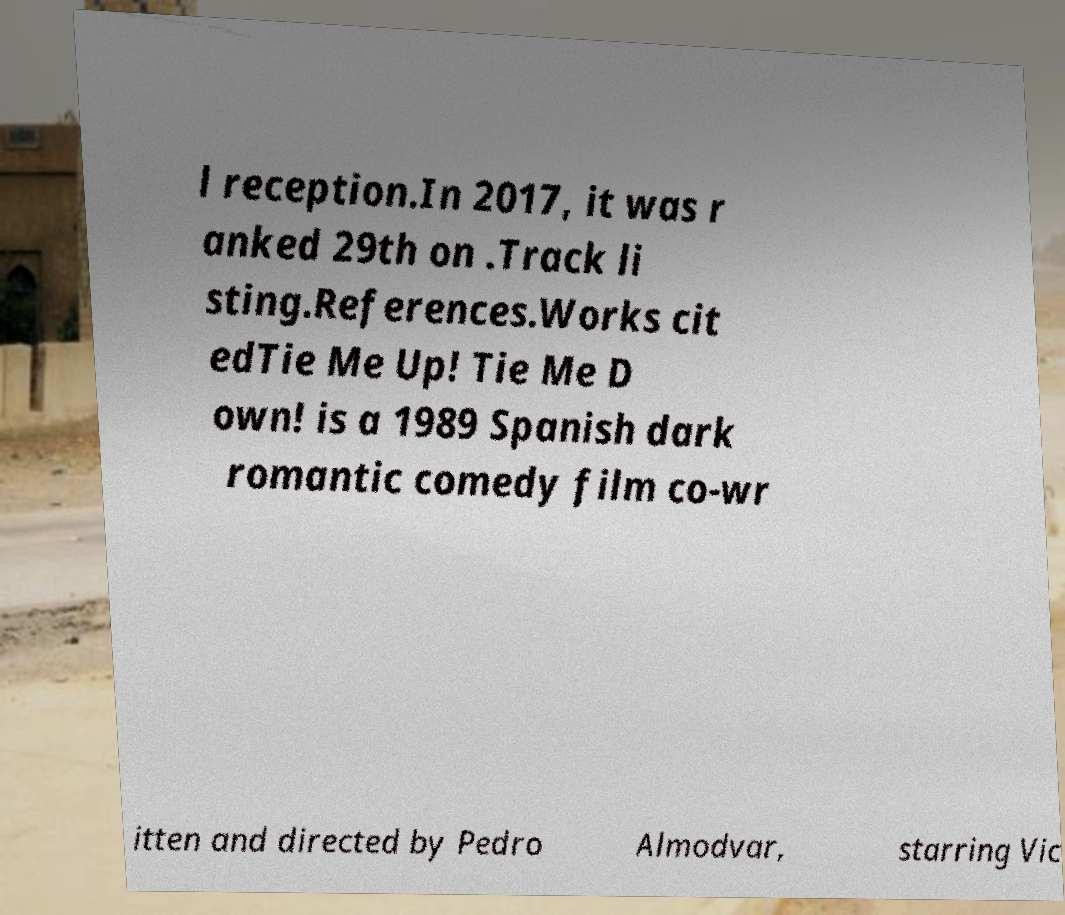Can you read and provide the text displayed in the image?This photo seems to have some interesting text. Can you extract and type it out for me? l reception.In 2017, it was r anked 29th on .Track li sting.References.Works cit edTie Me Up! Tie Me D own! is a 1989 Spanish dark romantic comedy film co-wr itten and directed by Pedro Almodvar, starring Vic 